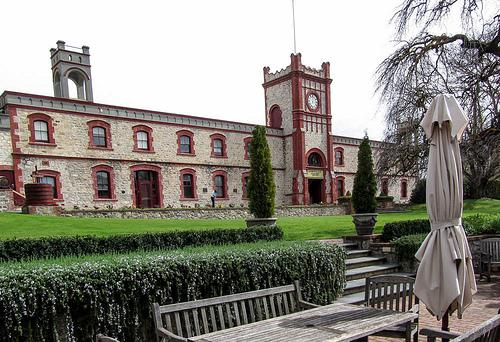Question: what color is the umbrella?
Choices:
A. Tan.
B. Pink.
C. Yellow.
D. Blue.
Answer with the letter. Answer: A Question: what material is the closest table?
Choices:
A. Metal.
B. Plastic.
C. Wood.
D. Stone.
Answer with the letter. Answer: C Question: where is the person standing?
Choices:
A. In the house.
B. In the garden.
C. On the road.
D. In the garage.
Answer with the letter. Answer: B Question: where in the picture is the umbrella?
Choices:
A. In the back.
B. On the right.
C. Above the people.
D. To the left.
Answer with the letter. Answer: B Question: what is in the top right corner?
Choices:
A. A building.
B. Mountains.
C. Branches.
D. Animals.
Answer with the letter. Answer: C Question: how many doorways face the camera?
Choices:
A. 4.
B. 5.
C. 2.
D. 6.
Answer with the letter. Answer: C 